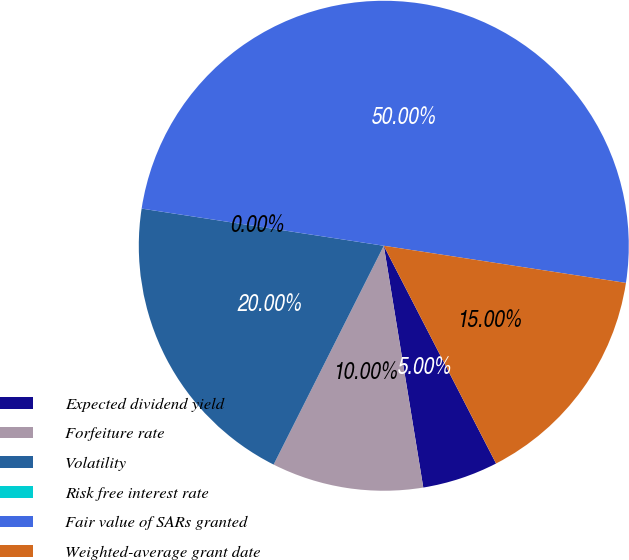<chart> <loc_0><loc_0><loc_500><loc_500><pie_chart><fcel>Expected dividend yield<fcel>Forfeiture rate<fcel>Volatility<fcel>Risk free interest rate<fcel>Fair value of SARs granted<fcel>Weighted-average grant date<nl><fcel>5.0%<fcel>10.0%<fcel>20.0%<fcel>0.0%<fcel>50.0%<fcel>15.0%<nl></chart> 